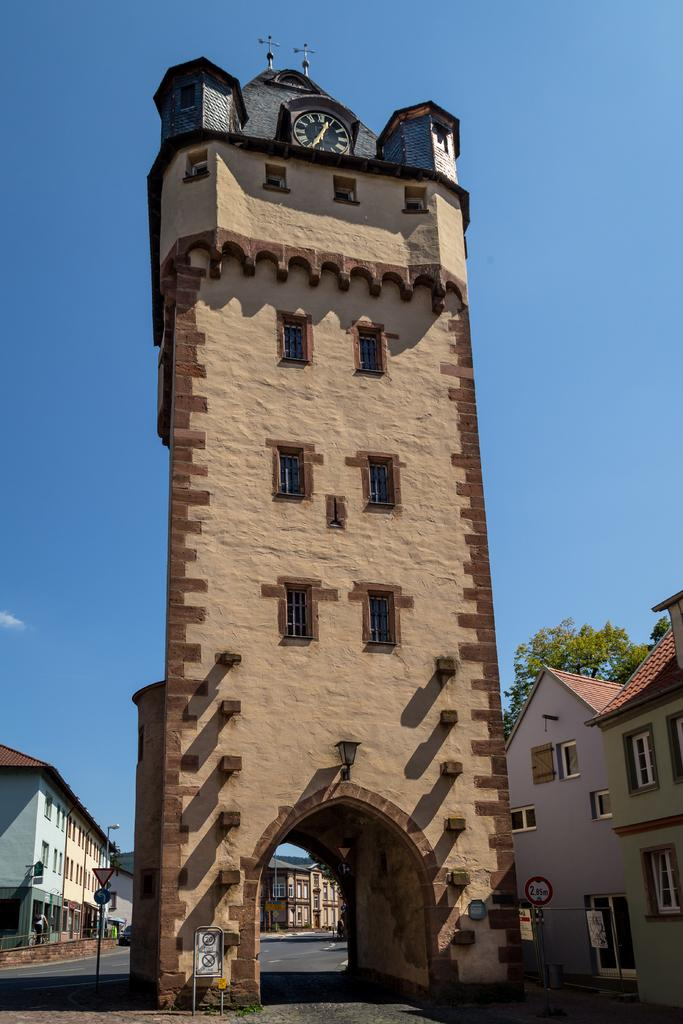What is the main structure in the picture? There is a clock tower in the picture. Are there any other buildings in the picture? Yes, there are buildings on either side of the clock tower. What can be seen in the background of the picture? There is a tree and a building in the background of the picture. What type of celery can be seen growing near the clock tower in the image? There is no celery present in the image; it features a clock tower, buildings, a tree, and a background building. 